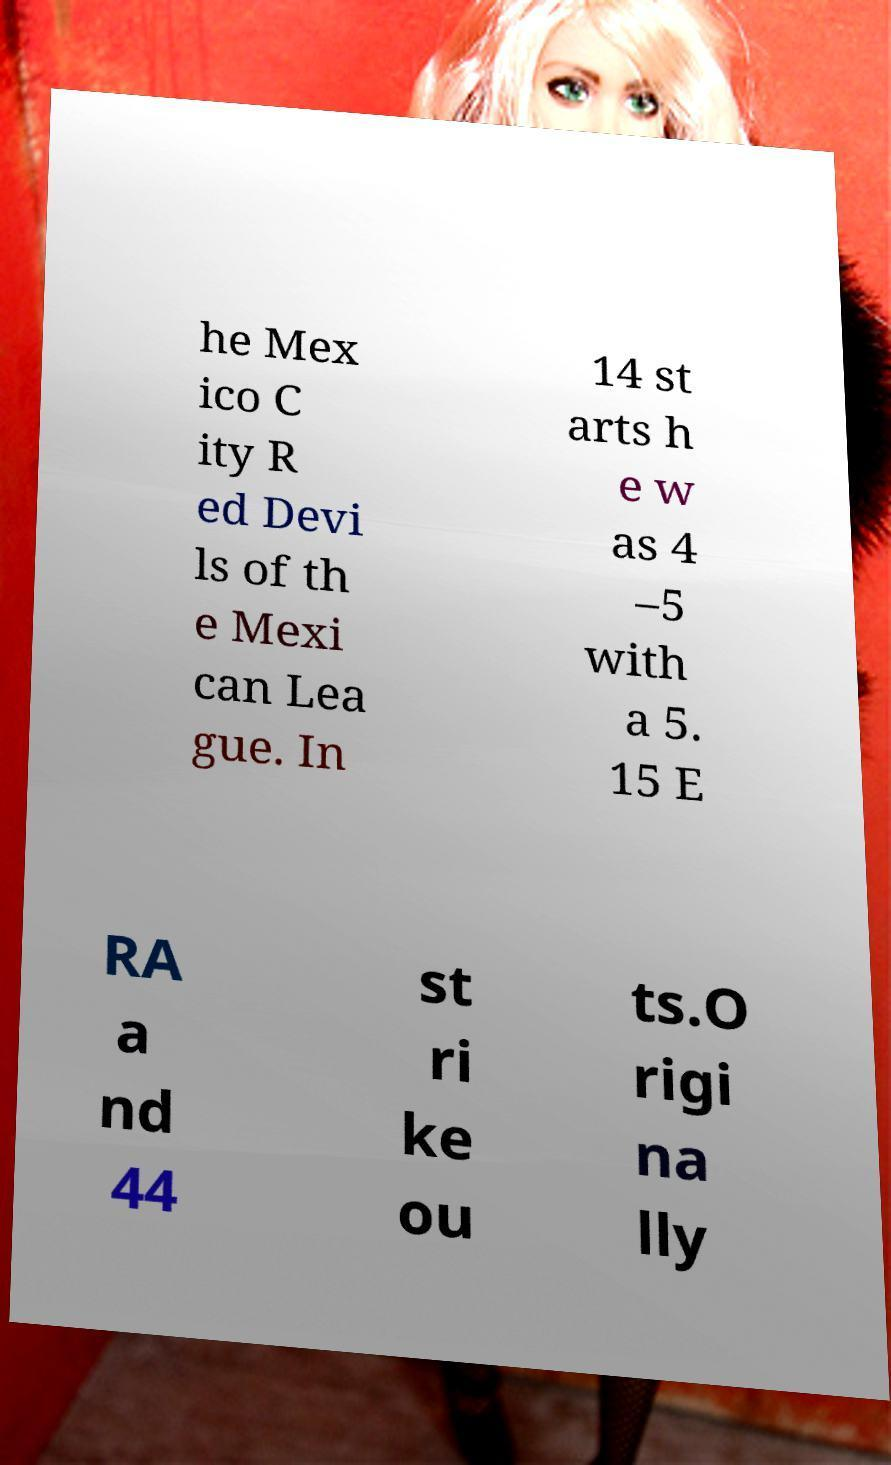Please identify and transcribe the text found in this image. he Mex ico C ity R ed Devi ls of th e Mexi can Lea gue. In 14 st arts h e w as 4 –5 with a 5. 15 E RA a nd 44 st ri ke ou ts.O rigi na lly 